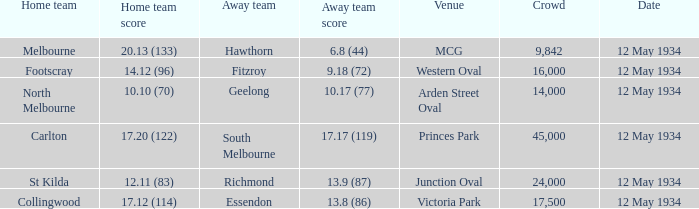Could you parse the entire table? {'header': ['Home team', 'Home team score', 'Away team', 'Away team score', 'Venue', 'Crowd', 'Date'], 'rows': [['Melbourne', '20.13 (133)', 'Hawthorn', '6.8 (44)', 'MCG', '9,842', '12 May 1934'], ['Footscray', '14.12 (96)', 'Fitzroy', '9.18 (72)', 'Western Oval', '16,000', '12 May 1934'], ['North Melbourne', '10.10 (70)', 'Geelong', '10.17 (77)', 'Arden Street Oval', '14,000', '12 May 1934'], ['Carlton', '17.20 (122)', 'South Melbourne', '17.17 (119)', 'Princes Park', '45,000', '12 May 1934'], ['St Kilda', '12.11 (83)', 'Richmond', '13.9 (87)', 'Junction Oval', '24,000', '12 May 1934'], ['Collingwood', '17.12 (114)', 'Essendon', '13.8 (86)', 'Victoria Park', '17,500', '12 May 1934']]} Which home team played the Away team from Richmond? St Kilda. 